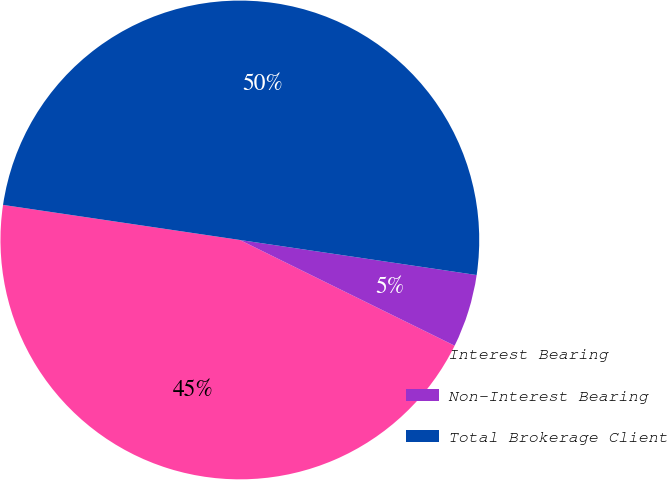Convert chart. <chart><loc_0><loc_0><loc_500><loc_500><pie_chart><fcel>Interest Bearing<fcel>Non-Interest Bearing<fcel>Total Brokerage Client<nl><fcel>45.06%<fcel>4.94%<fcel>50.0%<nl></chart> 